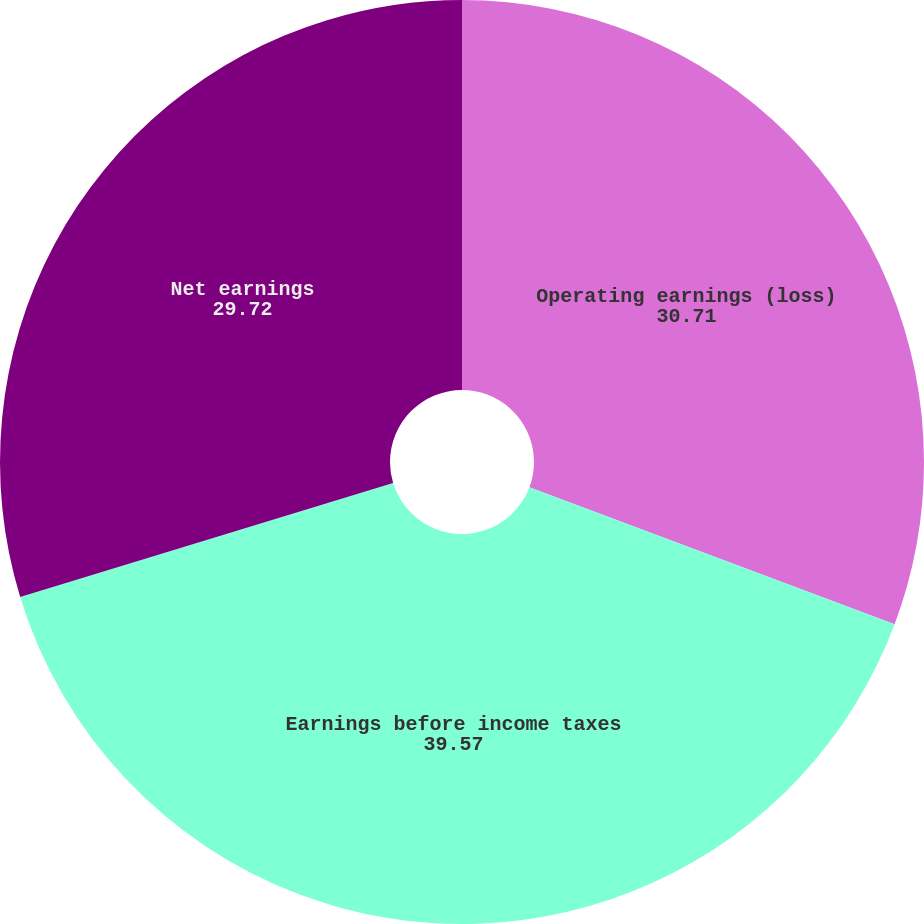<chart> <loc_0><loc_0><loc_500><loc_500><pie_chart><fcel>Operating earnings (loss)<fcel>Earnings before income taxes<fcel>Net earnings<nl><fcel>30.71%<fcel>39.57%<fcel>29.72%<nl></chart> 